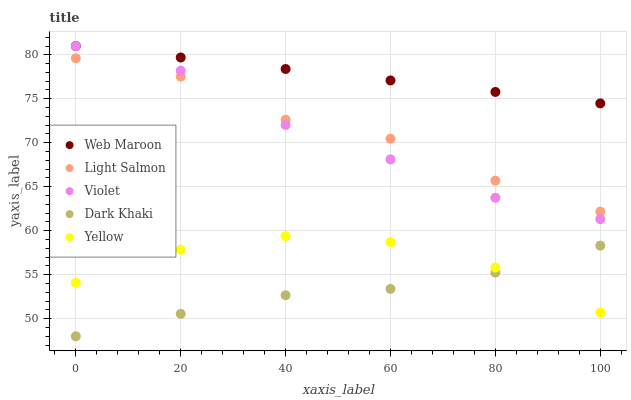Does Dark Khaki have the minimum area under the curve?
Answer yes or no. Yes. Does Web Maroon have the maximum area under the curve?
Answer yes or no. Yes. Does Light Salmon have the minimum area under the curve?
Answer yes or no. No. Does Light Salmon have the maximum area under the curve?
Answer yes or no. No. Is Web Maroon the smoothest?
Answer yes or no. Yes. Is Light Salmon the roughest?
Answer yes or no. Yes. Is Light Salmon the smoothest?
Answer yes or no. No. Is Web Maroon the roughest?
Answer yes or no. No. Does Dark Khaki have the lowest value?
Answer yes or no. Yes. Does Light Salmon have the lowest value?
Answer yes or no. No. Does Violet have the highest value?
Answer yes or no. Yes. Does Light Salmon have the highest value?
Answer yes or no. No. Is Dark Khaki less than Violet?
Answer yes or no. Yes. Is Web Maroon greater than Yellow?
Answer yes or no. Yes. Does Dark Khaki intersect Yellow?
Answer yes or no. Yes. Is Dark Khaki less than Yellow?
Answer yes or no. No. Is Dark Khaki greater than Yellow?
Answer yes or no. No. Does Dark Khaki intersect Violet?
Answer yes or no. No. 